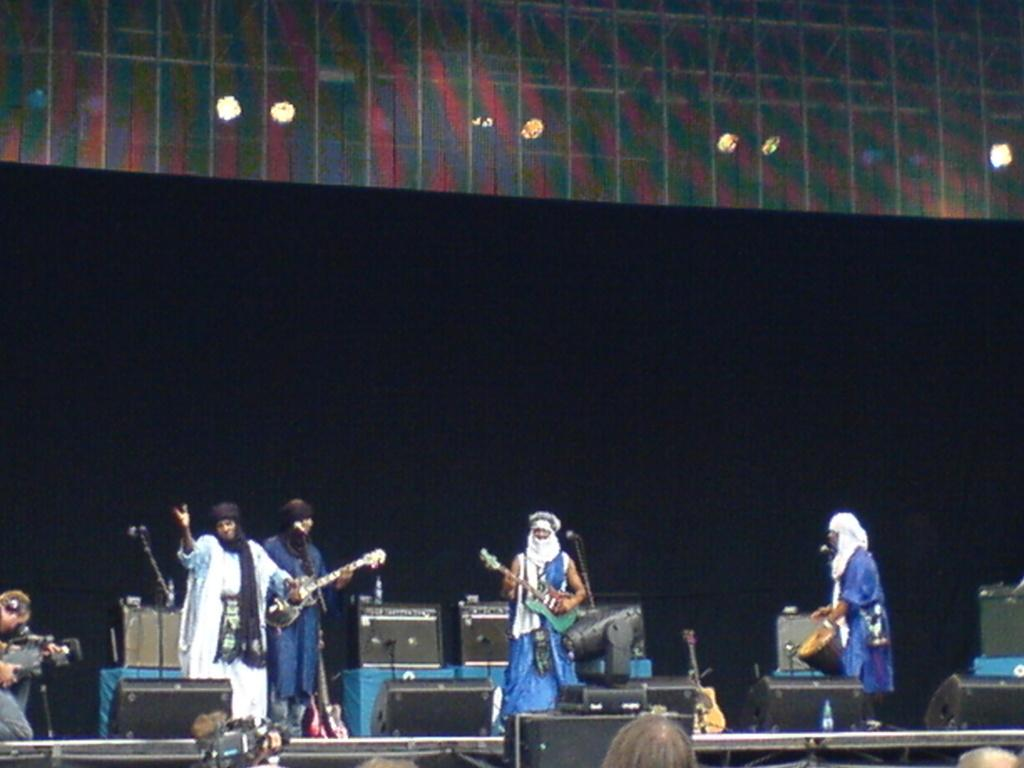What is happening in the image involving a group of people? The group of people are playing musical instruments. Where are the people playing musical instruments located? The group of people are on a stage. What object can be seen in the image that is commonly used for amplifying sound? There is a microphone in the image. What type of letter is being used to cast a spell on the stage in the image? There is no letter or magic present in the image; it features a group of people playing musical instruments on a stage with a microphone. 